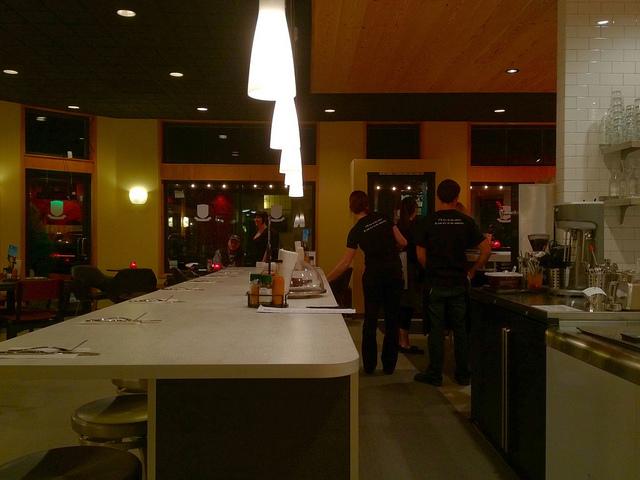Is the lights on?
Be succinct. Yes. Are the men bartenders?
Short answer required. Yes. What type of place is this?
Keep it brief. Restaurant. How many televisions are there in the mall?
Keep it brief. 0. Is this a bar?
Give a very brief answer. Yes. What is on the ceiling?
Write a very short answer. Lights. How many light fixtures are on?
Concise answer only. 5. How many people are in this photo?
Write a very short answer. 4. 